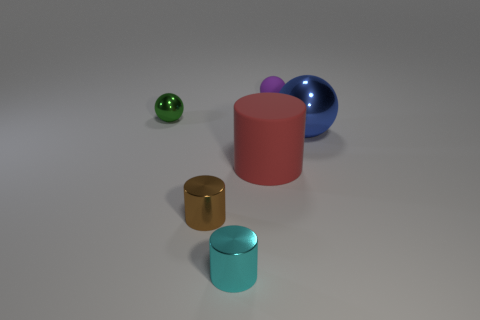What color is the shiny sphere in front of the metal ball left of the large sphere?
Your response must be concise. Blue. There is a sphere that is on the right side of the tiny purple sphere; what is its color?
Offer a terse response. Blue. What is the material of the large cylinder behind the tiny metallic cylinder that is to the left of the tiny cyan metallic cylinder?
Provide a short and direct response. Rubber. What is the material of the brown cylinder that is the same size as the cyan metal thing?
Provide a short and direct response. Metal. Is the number of spheres that are in front of the green ball greater than the number of blue objects that are to the left of the cyan thing?
Offer a very short reply. Yes. What shape is the rubber object that is the same size as the cyan shiny cylinder?
Your answer should be very brief. Sphere. There is a metal thing that is on the right side of the purple thing; what shape is it?
Offer a very short reply. Sphere. Is the number of red rubber cylinders that are behind the green sphere less than the number of red matte things that are in front of the blue metallic object?
Provide a succinct answer. Yes. There is a brown thing; is its size the same as the purple thing behind the green metal ball?
Your answer should be very brief. Yes. There is a small ball that is made of the same material as the big blue sphere; what color is it?
Your response must be concise. Green. 